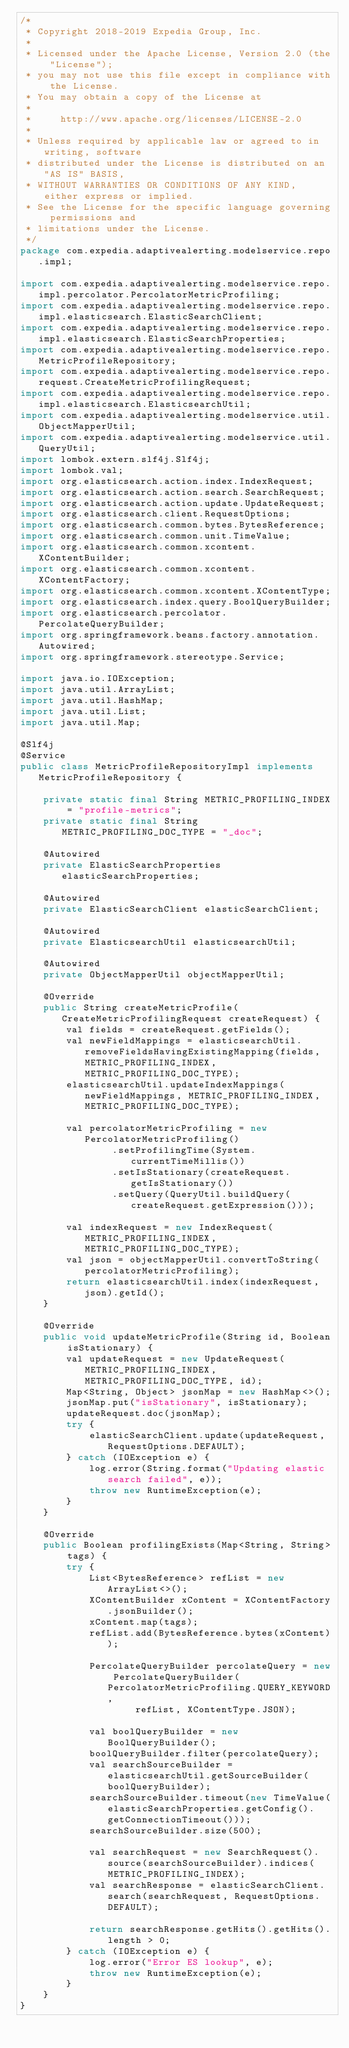Convert code to text. <code><loc_0><loc_0><loc_500><loc_500><_Java_>/*
 * Copyright 2018-2019 Expedia Group, Inc.
 *
 * Licensed under the Apache License, Version 2.0 (the "License");
 * you may not use this file except in compliance with the License.
 * You may obtain a copy of the License at
 *
 *     http://www.apache.org/licenses/LICENSE-2.0
 *
 * Unless required by applicable law or agreed to in writing, software
 * distributed under the License is distributed on an "AS IS" BASIS,
 * WITHOUT WARRANTIES OR CONDITIONS OF ANY KIND, either express or implied.
 * See the License for the specific language governing permissions and
 * limitations under the License.
 */
package com.expedia.adaptivealerting.modelservice.repo.impl;

import com.expedia.adaptivealerting.modelservice.repo.impl.percolator.PercolatorMetricProfiling;
import com.expedia.adaptivealerting.modelservice.repo.impl.elasticsearch.ElasticSearchClient;
import com.expedia.adaptivealerting.modelservice.repo.impl.elasticsearch.ElasticSearchProperties;
import com.expedia.adaptivealerting.modelservice.repo.MetricProfileRepository;
import com.expedia.adaptivealerting.modelservice.repo.request.CreateMetricProfilingRequest;
import com.expedia.adaptivealerting.modelservice.repo.impl.elasticsearch.ElasticsearchUtil;
import com.expedia.adaptivealerting.modelservice.util.ObjectMapperUtil;
import com.expedia.adaptivealerting.modelservice.util.QueryUtil;
import lombok.extern.slf4j.Slf4j;
import lombok.val;
import org.elasticsearch.action.index.IndexRequest;
import org.elasticsearch.action.search.SearchRequest;
import org.elasticsearch.action.update.UpdateRequest;
import org.elasticsearch.client.RequestOptions;
import org.elasticsearch.common.bytes.BytesReference;
import org.elasticsearch.common.unit.TimeValue;
import org.elasticsearch.common.xcontent.XContentBuilder;
import org.elasticsearch.common.xcontent.XContentFactory;
import org.elasticsearch.common.xcontent.XContentType;
import org.elasticsearch.index.query.BoolQueryBuilder;
import org.elasticsearch.percolator.PercolateQueryBuilder;
import org.springframework.beans.factory.annotation.Autowired;
import org.springframework.stereotype.Service;

import java.io.IOException;
import java.util.ArrayList;
import java.util.HashMap;
import java.util.List;
import java.util.Map;

@Slf4j
@Service
public class MetricProfileRepositoryImpl implements MetricProfileRepository {

    private static final String METRIC_PROFILING_INDEX = "profile-metrics";
    private static final String METRIC_PROFILING_DOC_TYPE = "_doc";

    @Autowired
    private ElasticSearchProperties elasticSearchProperties;

    @Autowired
    private ElasticSearchClient elasticSearchClient;

    @Autowired
    private ElasticsearchUtil elasticsearchUtil;

    @Autowired
    private ObjectMapperUtil objectMapperUtil;

    @Override
    public String createMetricProfile(CreateMetricProfilingRequest createRequest) {
        val fields = createRequest.getFields();
        val newFieldMappings = elasticsearchUtil.removeFieldsHavingExistingMapping(fields, METRIC_PROFILING_INDEX, METRIC_PROFILING_DOC_TYPE);
        elasticsearchUtil.updateIndexMappings(newFieldMappings, METRIC_PROFILING_INDEX, METRIC_PROFILING_DOC_TYPE);

        val percolatorMetricProfiling = new PercolatorMetricProfiling()
                .setProfilingTime(System.currentTimeMillis())
                .setIsStationary(createRequest.getIsStationary())
                .setQuery(QueryUtil.buildQuery(createRequest.getExpression()));

        val indexRequest = new IndexRequest(METRIC_PROFILING_INDEX, METRIC_PROFILING_DOC_TYPE);
        val json = objectMapperUtil.convertToString(percolatorMetricProfiling);
        return elasticsearchUtil.index(indexRequest, json).getId();
    }

    @Override
    public void updateMetricProfile(String id, Boolean isStationary) {
        val updateRequest = new UpdateRequest(METRIC_PROFILING_INDEX, METRIC_PROFILING_DOC_TYPE, id);
        Map<String, Object> jsonMap = new HashMap<>();
        jsonMap.put("isStationary", isStationary);
        updateRequest.doc(jsonMap);
        try {
            elasticSearchClient.update(updateRequest, RequestOptions.DEFAULT);
        } catch (IOException e) {
            log.error(String.format("Updating elastic search failed", e));
            throw new RuntimeException(e);
        }
    }

    @Override
    public Boolean profilingExists(Map<String, String> tags) {
        try {
            List<BytesReference> refList = new ArrayList<>();
            XContentBuilder xContent = XContentFactory.jsonBuilder();
            xContent.map(tags);
            refList.add(BytesReference.bytes(xContent));

            PercolateQueryBuilder percolateQuery = new PercolateQueryBuilder(PercolatorMetricProfiling.QUERY_KEYWORD,
                    refList, XContentType.JSON);

            val boolQueryBuilder = new BoolQueryBuilder();
            boolQueryBuilder.filter(percolateQuery);
            val searchSourceBuilder = elasticsearchUtil.getSourceBuilder(boolQueryBuilder);
            searchSourceBuilder.timeout(new TimeValue(elasticSearchProperties.getConfig().getConnectionTimeout()));
            searchSourceBuilder.size(500);

            val searchRequest = new SearchRequest().source(searchSourceBuilder).indices(METRIC_PROFILING_INDEX);
            val searchResponse = elasticSearchClient.search(searchRequest, RequestOptions.DEFAULT);

            return searchResponse.getHits().getHits().length > 0;
        } catch (IOException e) {
            log.error("Error ES lookup", e);
            throw new RuntimeException(e);
        }
    }
}
</code> 